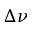Convert formula to latex. <formula><loc_0><loc_0><loc_500><loc_500>\Delta \nu</formula> 